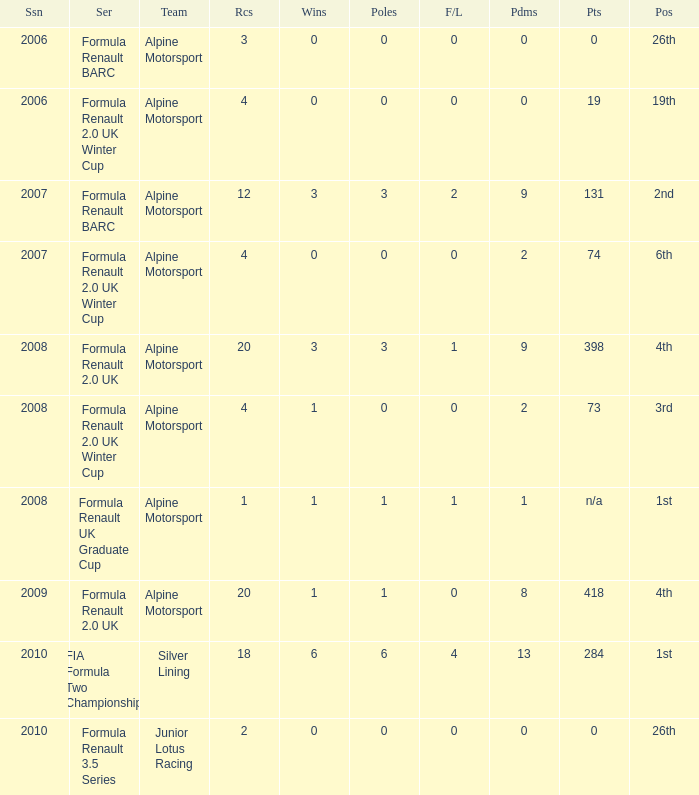What was the earliest season where podium was 9? 2007.0. 